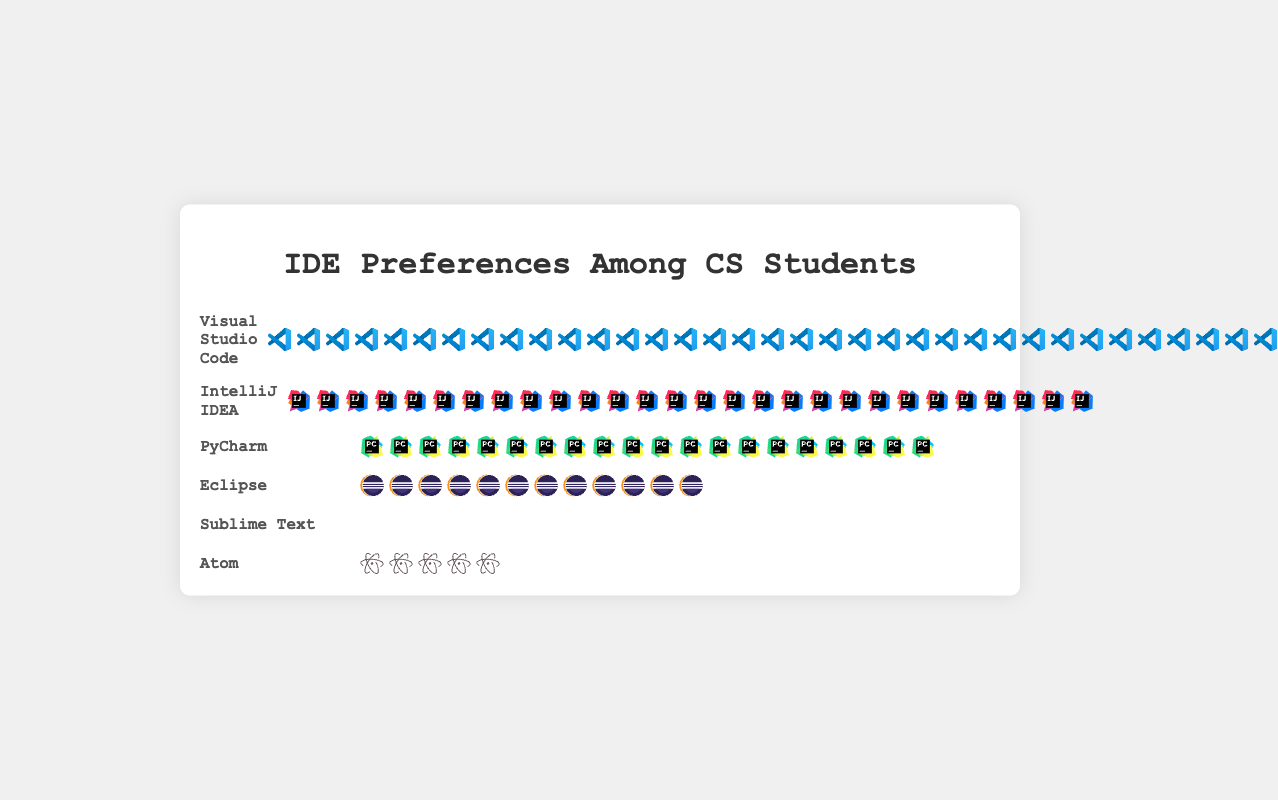What is the most preferred IDE among CS students? The most preferred IDE is indicated by the row with the most icons. Visual Studio Code has the highest number of icons.
Answer: Visual Studio Code How many students prefer PyCharm as their IDE? Each icon represents one student. By counting the PyCharm icons, we find that there are 20.
Answer: 20 Which IDEs have fewer than 10 students using them? Count the icons in each row to find the ones with fewer than 10: Sublime Text has 8, and Atom has 5.
Answer: Sublime Text, Atom What is the total number of students who prefer Eclipse and Sublime Text combined? Count the Eclipse icons (12) and the Sublime Text icons (8), then add them together: 12 + 8 = 20.
Answer: 20 Which IDEs have more students preferring them than Eclipse but fewer than Visual Studio Code? Visual Studio Code has 35 icons, and Eclipse has 12. IntelliJ IDEA (28) and PyCharm (20) fall in between these numbers.
Answer: IntelliJ IDEA, PyCharm What is the second most preferred IDE? The second most preferred IDE will have the second highest number of icons. IntelliJ IDEA has 28 icons, which is the second highest.
Answer: IntelliJ IDEA By how many students does the preference for Visual Studio Code exceed IntelliJ IDEA? Visual Studio Code has 35 icons, and IntelliJ IDEA has 28 icons. The difference is 35 - 28 = 7.
Answer: 7 What percentage of the total surveyed students prefer Atom? First, find the total number of students surveyed by adding all the icon counts: 35 + 28 + 20 + 12 + 8 + 5 = 108. Then, calculate the percentage for Atom's 5 students: (5 / 108) * 100 ≈ 4.63%.
Answer: ~4.63% How many times the number of students who prefer Atom prefer IntelliJ IDEA? Atom has 5 icons, and IntelliJ IDEA has 28 icons. The ratio is 28 / 5 = 5.6.
Answer: 5.6 List the IDEs in descending order of their popularity. Count the icons for each IDE and sort them: Visual Studio Code (35), IntelliJ IDEA (28), PyCharm (20), Eclipse (12), Sublime Text (8), Atom (5).
Answer: Visual Studio Code, IntelliJ IDEA, PyCharm, Eclipse, Sublime Text, Atom 